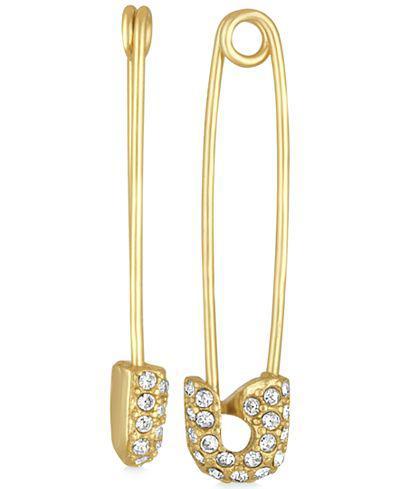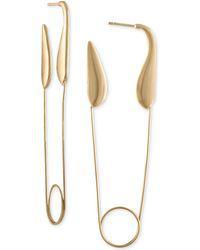The first image is the image on the left, the second image is the image on the right. For the images displayed, is the sentence "The left image contains a women wearing an ear ring." factually correct? Answer yes or no. No. The first image is the image on the left, the second image is the image on the right. Given the left and right images, does the statement "A person is wearing a safety pin in their ear in the image on the left." hold true? Answer yes or no. No. 